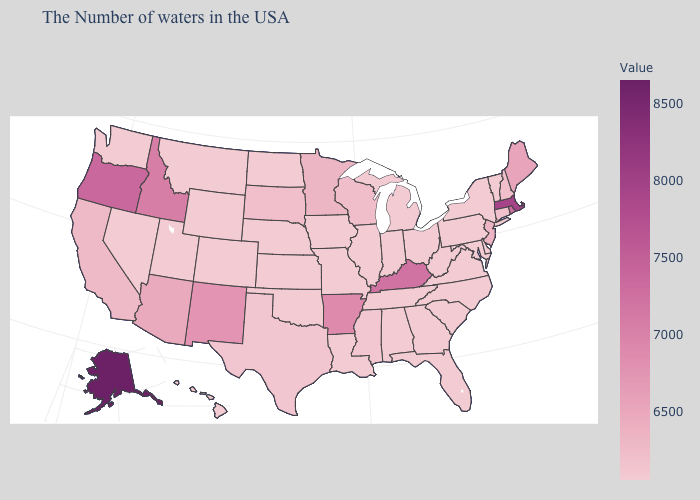Does Colorado have the lowest value in the USA?
Short answer required. Yes. Does Arkansas have the lowest value in the USA?
Be succinct. No. Among the states that border Arkansas , which have the highest value?
Write a very short answer. Texas. Which states have the highest value in the USA?
Answer briefly. Alaska. Does Kentucky have the highest value in the South?
Be succinct. Yes. Does Alaska have the highest value in the USA?
Concise answer only. Yes. Does the map have missing data?
Concise answer only. No. 